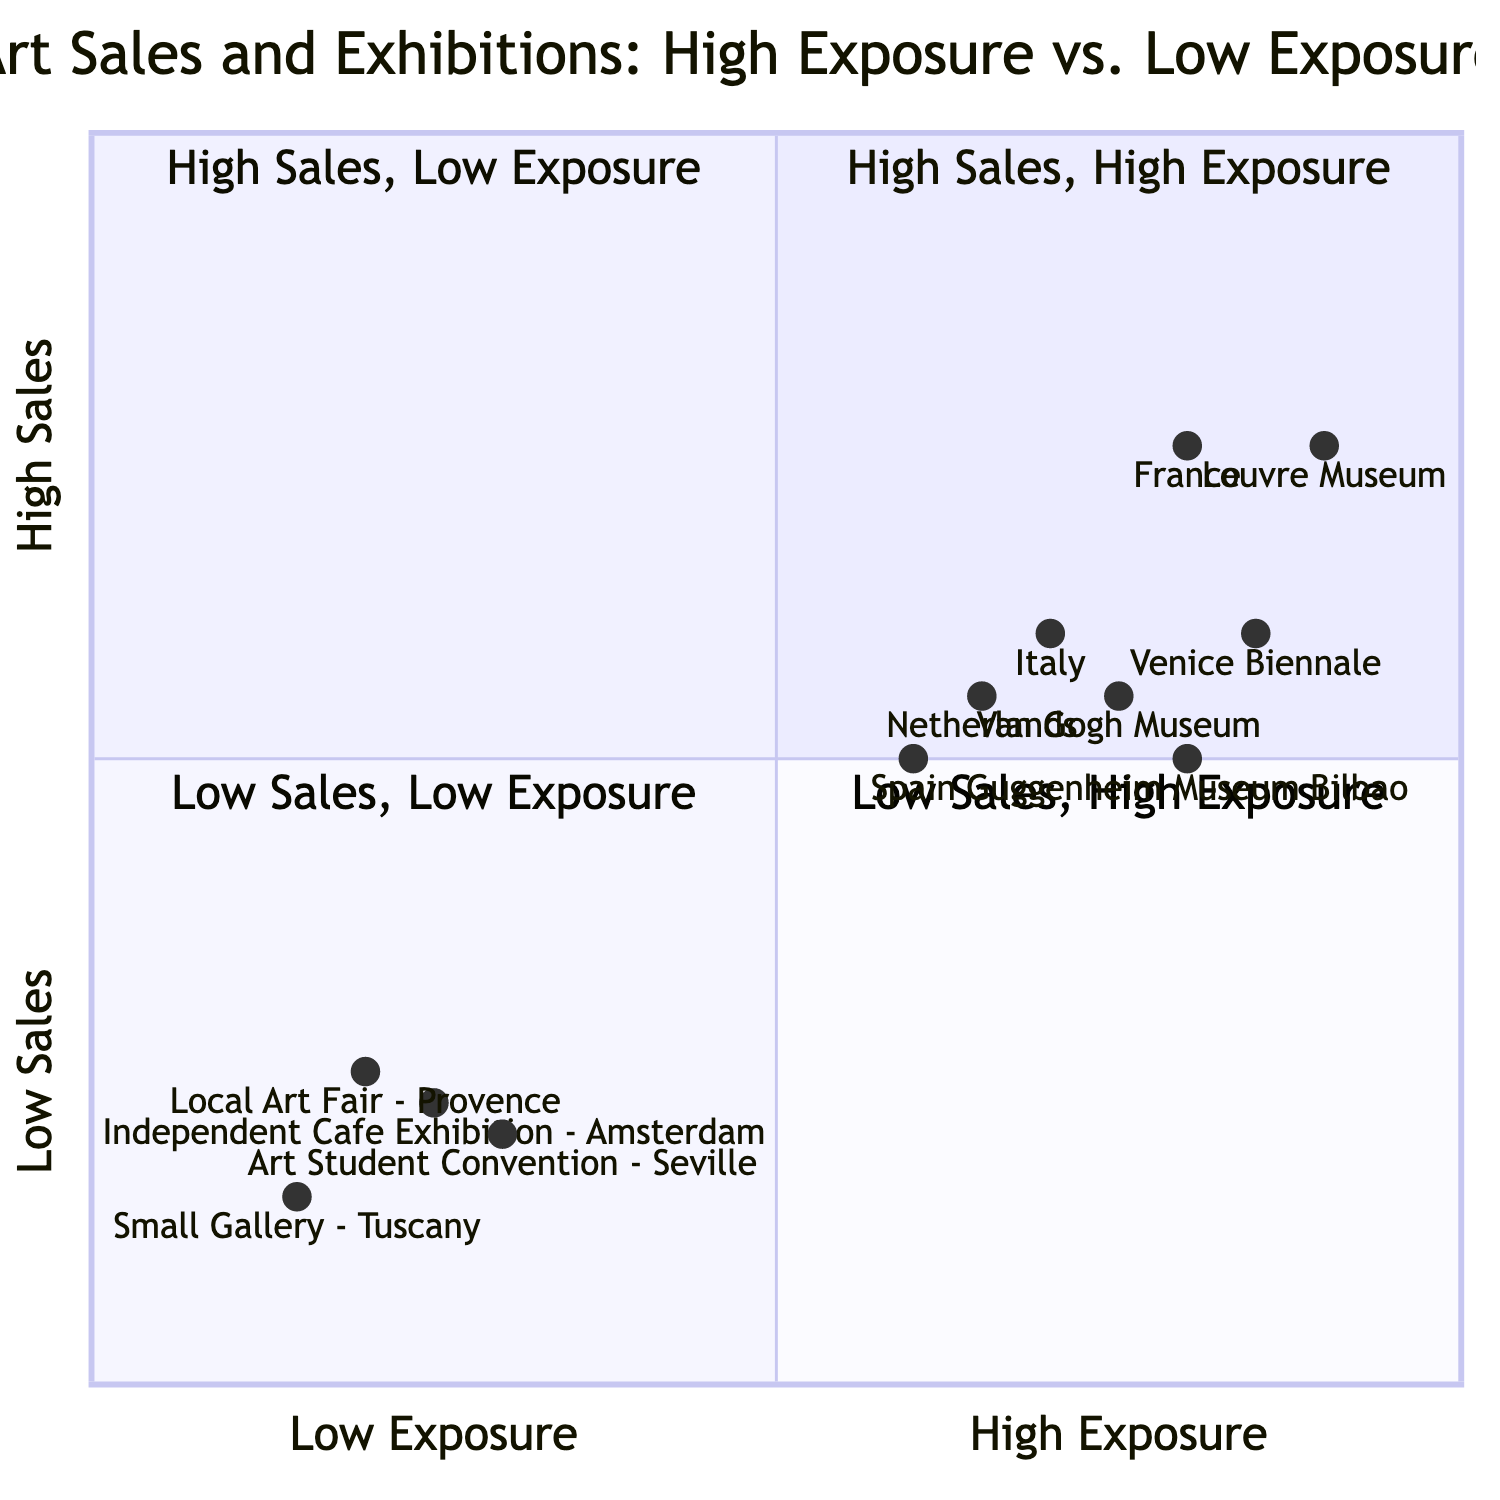What country has the highest art sales? By looking at the High Sales quadrant, France has the highest sales figure of 150,000, indicating it has the highest art sales among the countries listed.
Answer: France Which country is in the quadrant with Low Sales and Low Exposure? By analyzing the quadrant positions, Spain falls into the Low Sales and Low Exposure quadrant as its sales figure is 40,000 and it is associated with a local event that reflects low exposure.
Answer: Spain How many countries exhibited high exposure? Observing the High Exposure quadrant, there are four distinct entries, which represent the four countries exhibiting high exposure through notable museums or events.
Answer: Four What is the sales figure for Italy with Low Exposure? Italy's Low Exposure entry corresponds to "Small Gallery - Tuscany," showing a sales figure of 30,000, which represents the low sales from that exposure.
Answer: 30,000 Which exhibition has the lowest exposure response? The diagram shows that "Small Gallery - Tuscany" has the lowest coordinates, marking it as the exhibition with the least exposure and lowest sales.
Answer: Small Gallery - Tuscany Which country has higher sales, France or Spain? By comparing the sales figures, France at 150,000 significantly surpasses Spain, which has sales of 100,000, indicating that France has higher sales.
Answer: France What is the sales figure for the Van Gogh Museum? The coordinates for the Van Gogh Museum place it in the High Sales and High Exposure quadrant, and the sales figure is 110,000, indicating its successful exposure and sales.
Answer: 110,000 Which country is associated with the highest exposure venue? Among the listed venues, the "Louvre Museum" represents the highest exposure, associated with France, indicating its prestigious status and high visitor numbers.
Answer: France What is the quadrant for the Independent Cafe Exhibition? The Independent Cafe Exhibition is plotted in the Low Sales and Low Exposure quadrant, indicating a relationship of limited sales potential due to its exposure level.
Answer: Low Sales and Low Exposure 